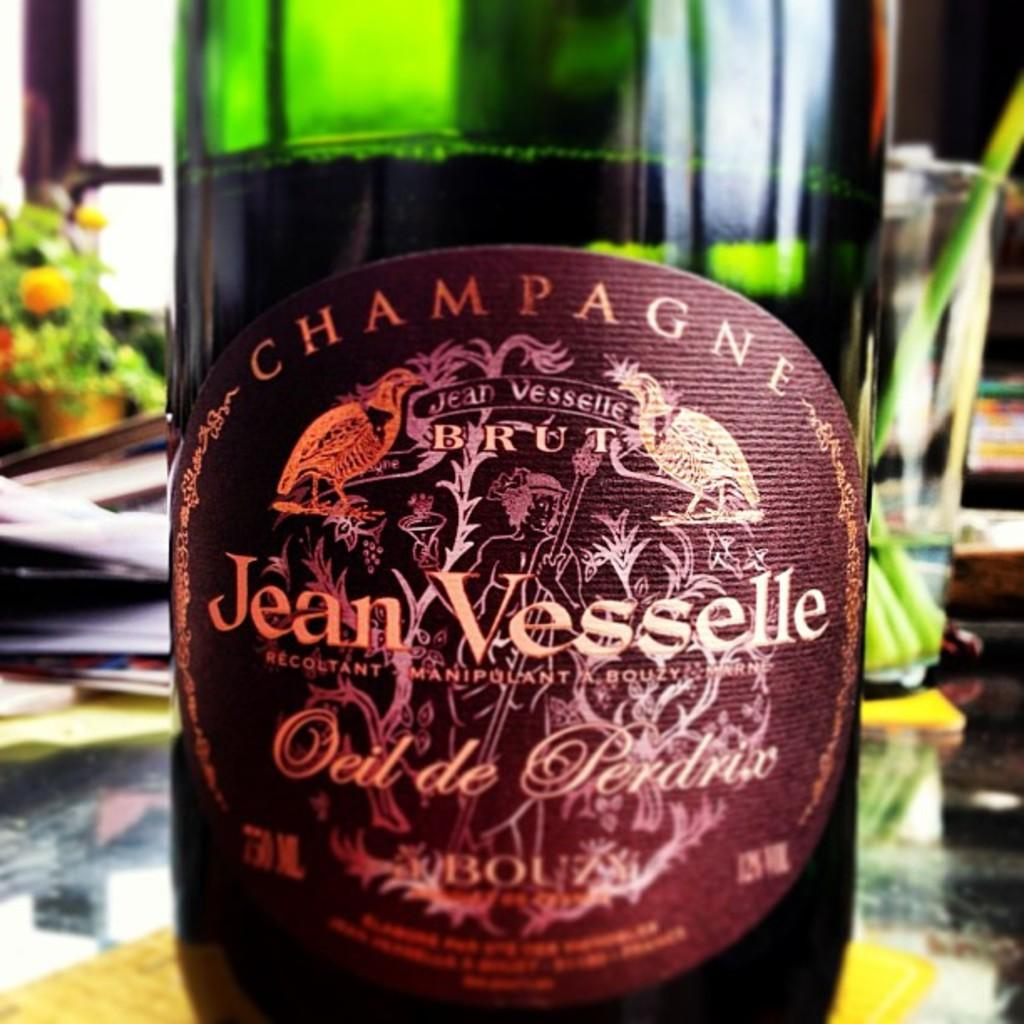<image>
Offer a succinct explanation of the picture presented. A bottle of champagne has Jean Vesselle on the label. 